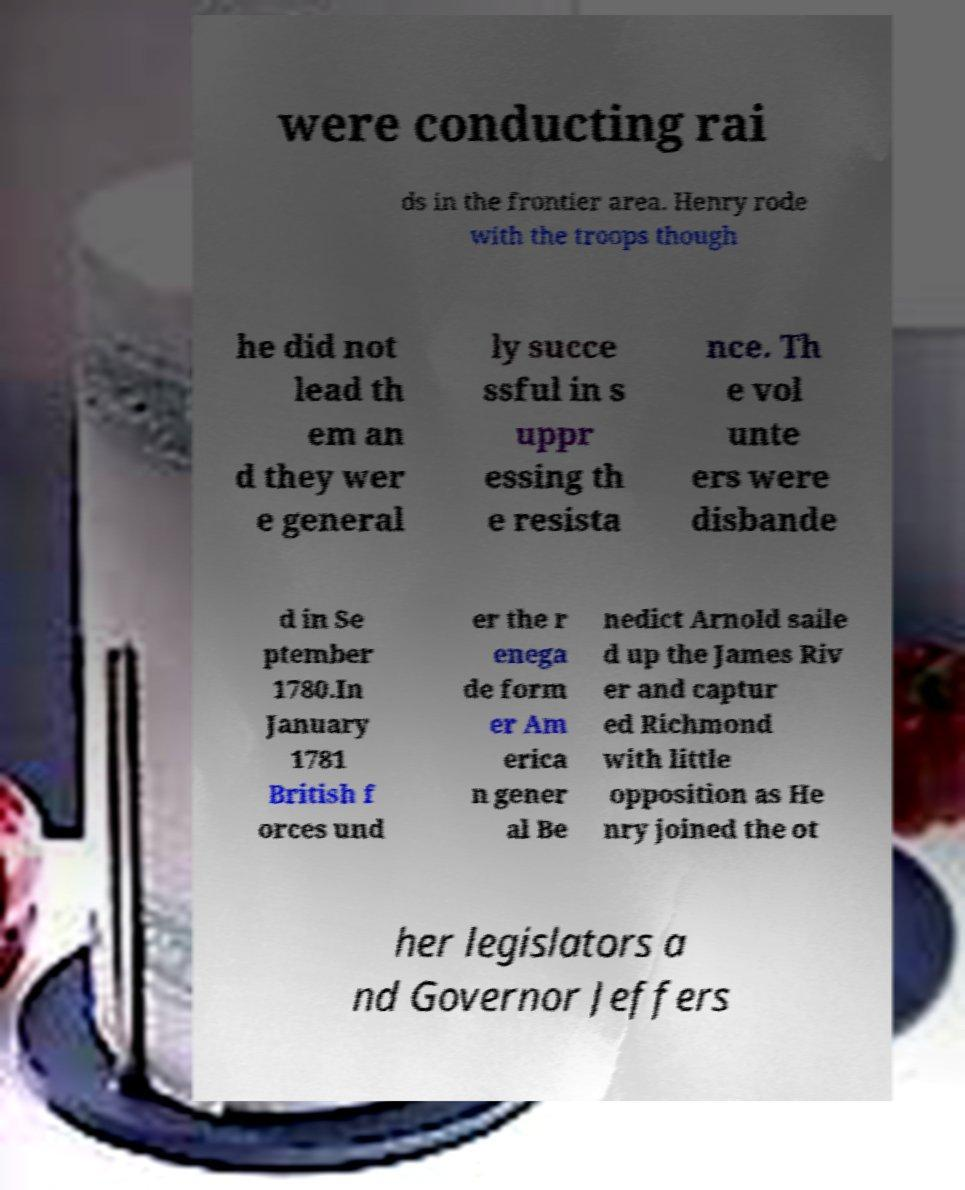For documentation purposes, I need the text within this image transcribed. Could you provide that? were conducting rai ds in the frontier area. Henry rode with the troops though he did not lead th em an d they wer e general ly succe ssful in s uppr essing th e resista nce. Th e vol unte ers were disbande d in Se ptember 1780.In January 1781 British f orces und er the r enega de form er Am erica n gener al Be nedict Arnold saile d up the James Riv er and captur ed Richmond with little opposition as He nry joined the ot her legislators a nd Governor Jeffers 